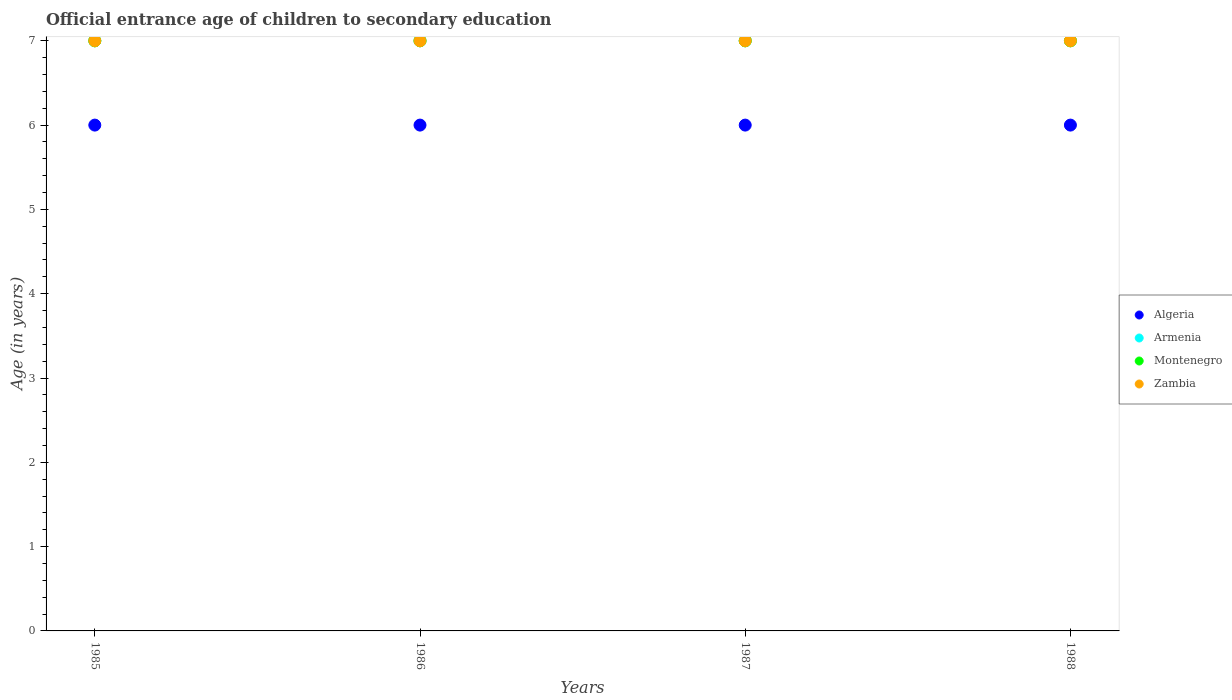How many different coloured dotlines are there?
Your answer should be compact. 4. Is the number of dotlines equal to the number of legend labels?
Offer a very short reply. Yes. What is the secondary school starting age of children in Armenia in 1987?
Keep it short and to the point. 7. Across all years, what is the maximum secondary school starting age of children in Armenia?
Make the answer very short. 7. In which year was the secondary school starting age of children in Armenia minimum?
Provide a succinct answer. 1985. What is the difference between the secondary school starting age of children in Algeria in 1985 and the secondary school starting age of children in Zambia in 1987?
Offer a terse response. -1. What is the average secondary school starting age of children in Armenia per year?
Offer a terse response. 7. What is the ratio of the secondary school starting age of children in Armenia in 1986 to that in 1988?
Make the answer very short. 1. Is the secondary school starting age of children in Montenegro in 1986 less than that in 1987?
Give a very brief answer. No. Is the difference between the secondary school starting age of children in Zambia in 1985 and 1986 greater than the difference between the secondary school starting age of children in Montenegro in 1985 and 1986?
Offer a very short reply. No. Is it the case that in every year, the sum of the secondary school starting age of children in Zambia and secondary school starting age of children in Armenia  is greater than the secondary school starting age of children in Montenegro?
Keep it short and to the point. Yes. Is the secondary school starting age of children in Zambia strictly greater than the secondary school starting age of children in Armenia over the years?
Provide a short and direct response. No. Is the secondary school starting age of children in Montenegro strictly less than the secondary school starting age of children in Armenia over the years?
Your answer should be compact. No. How many years are there in the graph?
Ensure brevity in your answer.  4. What is the difference between two consecutive major ticks on the Y-axis?
Your answer should be very brief. 1. Where does the legend appear in the graph?
Ensure brevity in your answer.  Center right. How many legend labels are there?
Your response must be concise. 4. How are the legend labels stacked?
Your answer should be very brief. Vertical. What is the title of the graph?
Your response must be concise. Official entrance age of children to secondary education. What is the label or title of the Y-axis?
Your response must be concise. Age (in years). What is the Age (in years) in Algeria in 1985?
Your answer should be very brief. 6. What is the Age (in years) of Montenegro in 1985?
Ensure brevity in your answer.  7. What is the Age (in years) of Zambia in 1986?
Your answer should be compact. 7. What is the Age (in years) of Armenia in 1987?
Provide a succinct answer. 7. What is the Age (in years) in Armenia in 1988?
Offer a terse response. 7. Across all years, what is the maximum Age (in years) of Armenia?
Keep it short and to the point. 7. Across all years, what is the maximum Age (in years) of Montenegro?
Ensure brevity in your answer.  7. What is the total Age (in years) of Armenia in the graph?
Provide a short and direct response. 28. What is the total Age (in years) in Montenegro in the graph?
Make the answer very short. 28. What is the difference between the Age (in years) in Armenia in 1985 and that in 1986?
Offer a terse response. 0. What is the difference between the Age (in years) of Montenegro in 1985 and that in 1986?
Your answer should be very brief. 0. What is the difference between the Age (in years) in Algeria in 1985 and that in 1987?
Provide a short and direct response. 0. What is the difference between the Age (in years) of Montenegro in 1985 and that in 1987?
Provide a succinct answer. 0. What is the difference between the Age (in years) in Zambia in 1985 and that in 1987?
Ensure brevity in your answer.  0. What is the difference between the Age (in years) of Algeria in 1985 and that in 1988?
Provide a succinct answer. 0. What is the difference between the Age (in years) of Montenegro in 1985 and that in 1988?
Give a very brief answer. 0. What is the difference between the Age (in years) in Zambia in 1986 and that in 1987?
Your answer should be very brief. 0. What is the difference between the Age (in years) of Montenegro in 1986 and that in 1988?
Your response must be concise. 0. What is the difference between the Age (in years) of Zambia in 1986 and that in 1988?
Keep it short and to the point. 0. What is the difference between the Age (in years) in Algeria in 1987 and that in 1988?
Ensure brevity in your answer.  0. What is the difference between the Age (in years) of Montenegro in 1987 and that in 1988?
Your answer should be very brief. 0. What is the difference between the Age (in years) of Algeria in 1985 and the Age (in years) of Zambia in 1986?
Offer a terse response. -1. What is the difference between the Age (in years) of Armenia in 1985 and the Age (in years) of Montenegro in 1986?
Make the answer very short. 0. What is the difference between the Age (in years) of Armenia in 1985 and the Age (in years) of Zambia in 1986?
Make the answer very short. 0. What is the difference between the Age (in years) in Montenegro in 1985 and the Age (in years) in Zambia in 1986?
Provide a short and direct response. 0. What is the difference between the Age (in years) of Algeria in 1985 and the Age (in years) of Armenia in 1987?
Provide a succinct answer. -1. What is the difference between the Age (in years) in Algeria in 1985 and the Age (in years) in Zambia in 1987?
Make the answer very short. -1. What is the difference between the Age (in years) of Algeria in 1985 and the Age (in years) of Armenia in 1988?
Offer a terse response. -1. What is the difference between the Age (in years) in Algeria in 1986 and the Age (in years) in Armenia in 1987?
Your answer should be very brief. -1. What is the difference between the Age (in years) in Armenia in 1986 and the Age (in years) in Zambia in 1987?
Ensure brevity in your answer.  0. What is the difference between the Age (in years) of Algeria in 1986 and the Age (in years) of Zambia in 1988?
Give a very brief answer. -1. What is the difference between the Age (in years) in Armenia in 1986 and the Age (in years) in Montenegro in 1988?
Offer a very short reply. 0. What is the difference between the Age (in years) in Montenegro in 1986 and the Age (in years) in Zambia in 1988?
Your answer should be compact. 0. What is the difference between the Age (in years) of Algeria in 1987 and the Age (in years) of Armenia in 1988?
Make the answer very short. -1. What is the difference between the Age (in years) of Algeria in 1987 and the Age (in years) of Montenegro in 1988?
Provide a succinct answer. -1. What is the average Age (in years) of Algeria per year?
Keep it short and to the point. 6. What is the average Age (in years) in Armenia per year?
Your answer should be very brief. 7. What is the average Age (in years) in Zambia per year?
Ensure brevity in your answer.  7. In the year 1985, what is the difference between the Age (in years) in Algeria and Age (in years) in Zambia?
Give a very brief answer. -1. In the year 1985, what is the difference between the Age (in years) in Armenia and Age (in years) in Montenegro?
Provide a short and direct response. 0. In the year 1985, what is the difference between the Age (in years) in Armenia and Age (in years) in Zambia?
Keep it short and to the point. 0. In the year 1986, what is the difference between the Age (in years) of Armenia and Age (in years) of Zambia?
Offer a terse response. 0. In the year 1986, what is the difference between the Age (in years) of Montenegro and Age (in years) of Zambia?
Provide a short and direct response. 0. In the year 1987, what is the difference between the Age (in years) in Armenia and Age (in years) in Zambia?
Provide a short and direct response. 0. In the year 1988, what is the difference between the Age (in years) in Algeria and Age (in years) in Zambia?
Your answer should be compact. -1. What is the ratio of the Age (in years) of Armenia in 1985 to that in 1986?
Give a very brief answer. 1. What is the ratio of the Age (in years) of Zambia in 1985 to that in 1986?
Give a very brief answer. 1. What is the ratio of the Age (in years) of Armenia in 1985 to that in 1987?
Ensure brevity in your answer.  1. What is the ratio of the Age (in years) in Algeria in 1985 to that in 1988?
Offer a very short reply. 1. What is the ratio of the Age (in years) in Montenegro in 1985 to that in 1988?
Your answer should be very brief. 1. What is the ratio of the Age (in years) of Zambia in 1985 to that in 1988?
Your answer should be very brief. 1. What is the ratio of the Age (in years) in Algeria in 1986 to that in 1987?
Your response must be concise. 1. What is the ratio of the Age (in years) in Montenegro in 1986 to that in 1987?
Your response must be concise. 1. What is the ratio of the Age (in years) in Zambia in 1986 to that in 1987?
Offer a very short reply. 1. What is the ratio of the Age (in years) of Zambia in 1986 to that in 1988?
Give a very brief answer. 1. What is the ratio of the Age (in years) in Montenegro in 1987 to that in 1988?
Give a very brief answer. 1. What is the difference between the highest and the second highest Age (in years) in Algeria?
Offer a terse response. 0. What is the difference between the highest and the second highest Age (in years) of Armenia?
Provide a short and direct response. 0. What is the difference between the highest and the second highest Age (in years) in Zambia?
Ensure brevity in your answer.  0. What is the difference between the highest and the lowest Age (in years) in Algeria?
Your answer should be compact. 0. What is the difference between the highest and the lowest Age (in years) in Montenegro?
Make the answer very short. 0. What is the difference between the highest and the lowest Age (in years) in Zambia?
Offer a very short reply. 0. 